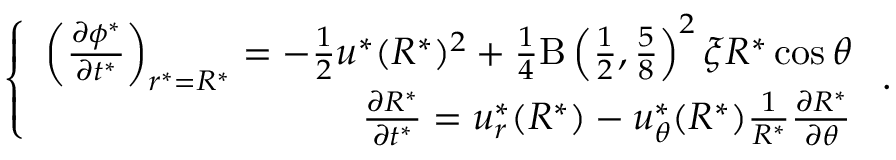<formula> <loc_0><loc_0><loc_500><loc_500>\left \{ \begin{array} { r } { \left ( \frac { \partial \phi ^ { * } } { \partial t ^ { * } } \right ) _ { r ^ { * } = R ^ { * } } = - \frac { 1 } { 2 } u ^ { * } ( R ^ { * } ) ^ { 2 } + \frac { 1 } { 4 } B \left ( \frac { 1 } { 2 } , \frac { 5 } { 8 } \right ) ^ { 2 } \xi R ^ { * } \cos \theta } \\ { \frac { \partial R ^ { * } } { \partial t ^ { * } } = u _ { r } ^ { * } ( R ^ { * } ) - u _ { \theta } ^ { * } ( R ^ { * } ) \frac { 1 } { R ^ { * } } \frac { \partial R ^ { * } } { \partial \theta } } \end{array} .</formula> 